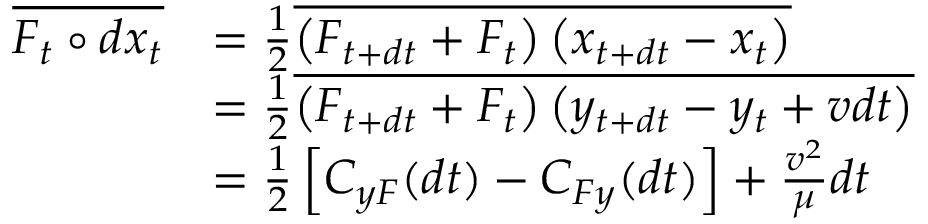Convert formula to latex. <formula><loc_0><loc_0><loc_500><loc_500>\begin{array} { r l } { \overline { { F _ { t } \circ d { x } _ { t } } } } & { = \frac { 1 } { 2 } \overline { { \left ( F _ { t + d t } + F _ { t } \right ) \left ( x _ { t + d t } - x _ { t } \right ) } } } \\ & { = \frac { 1 } { 2 } \overline { { \left ( F _ { t + d t } + F _ { t } \right ) \left ( y _ { t + d t } - y _ { t } + v d t \right ) } } } \\ & { = \frac { 1 } { 2 } \left [ C _ { y F } ( d t ) - C _ { F y } ( d t ) \right ] + \frac { v ^ { 2 } } { \mu } d t } \end{array}</formula> 